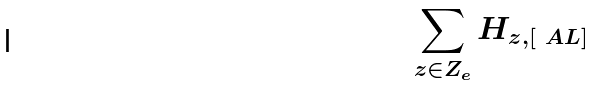<formula> <loc_0><loc_0><loc_500><loc_500>\sum _ { z \in Z _ { e } } H _ { z , [ \ A L ] }</formula> 